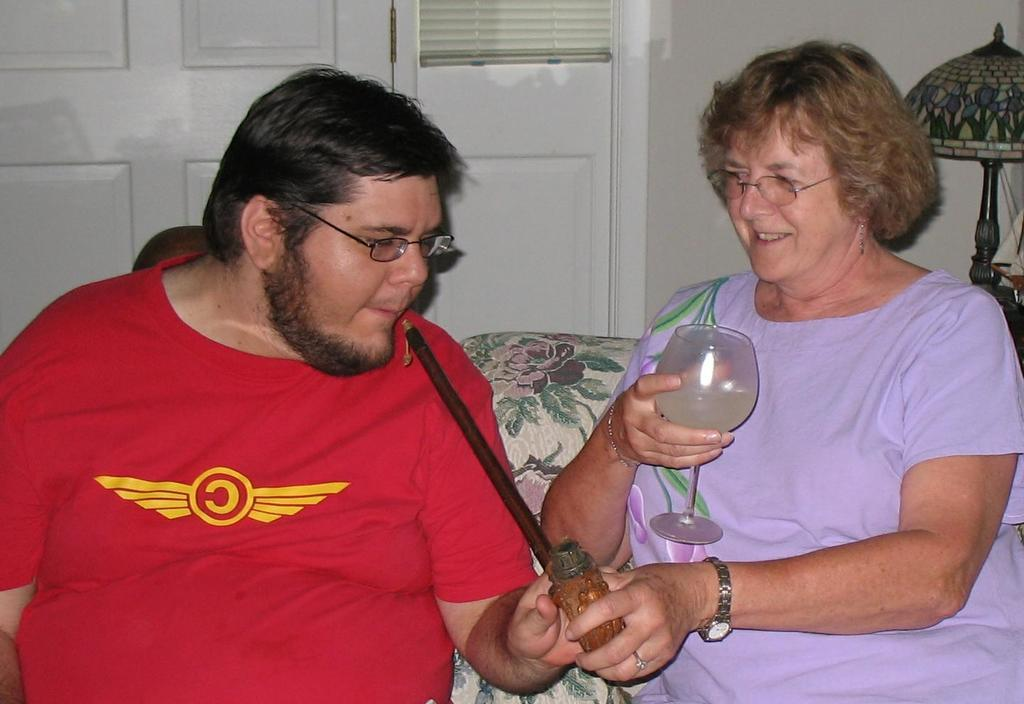How many people are in the image? There are two people in the image, a man and a woman. What are the man and woman doing in the image? The man and woman are sitting on a couch. What is the woman holding in the image? The woman is holding a glass. What are the man and woman holding together? The man and woman are holding a stick. What can be seen in the background of the image? There is a door visible in the image, and it is connected to a wall. What type of poison is the man and woman using to poison the library in the image? There is no poison or library present in the image. 